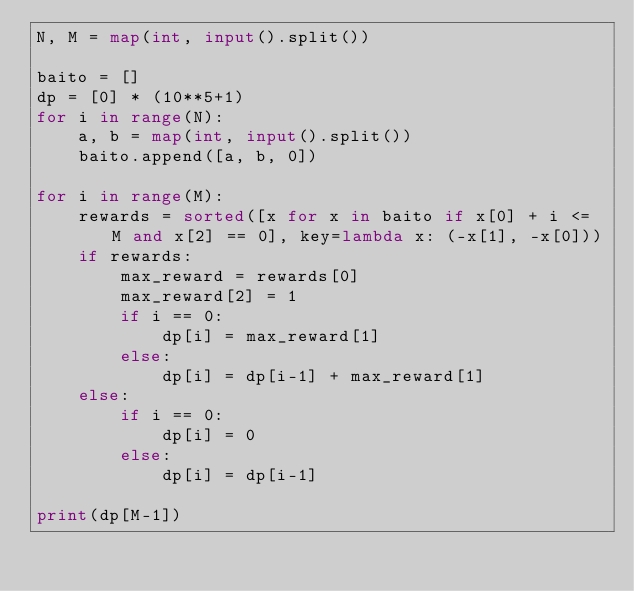Convert code to text. <code><loc_0><loc_0><loc_500><loc_500><_Python_>N, M = map(int, input().split())

baito = []
dp = [0] * (10**5+1)
for i in range(N):
    a, b = map(int, input().split())
    baito.append([a, b, 0])

for i in range(M):
    rewards = sorted([x for x in baito if x[0] + i <= M and x[2] == 0], key=lambda x: (-x[1], -x[0]))
    if rewards:
        max_reward = rewards[0]
        max_reward[2] = 1
        if i == 0:
            dp[i] = max_reward[1]
        else:
            dp[i] = dp[i-1] + max_reward[1]
    else:
        if i == 0:
            dp[i] = 0
        else:
            dp[i] = dp[i-1]

print(dp[M-1])
</code> 